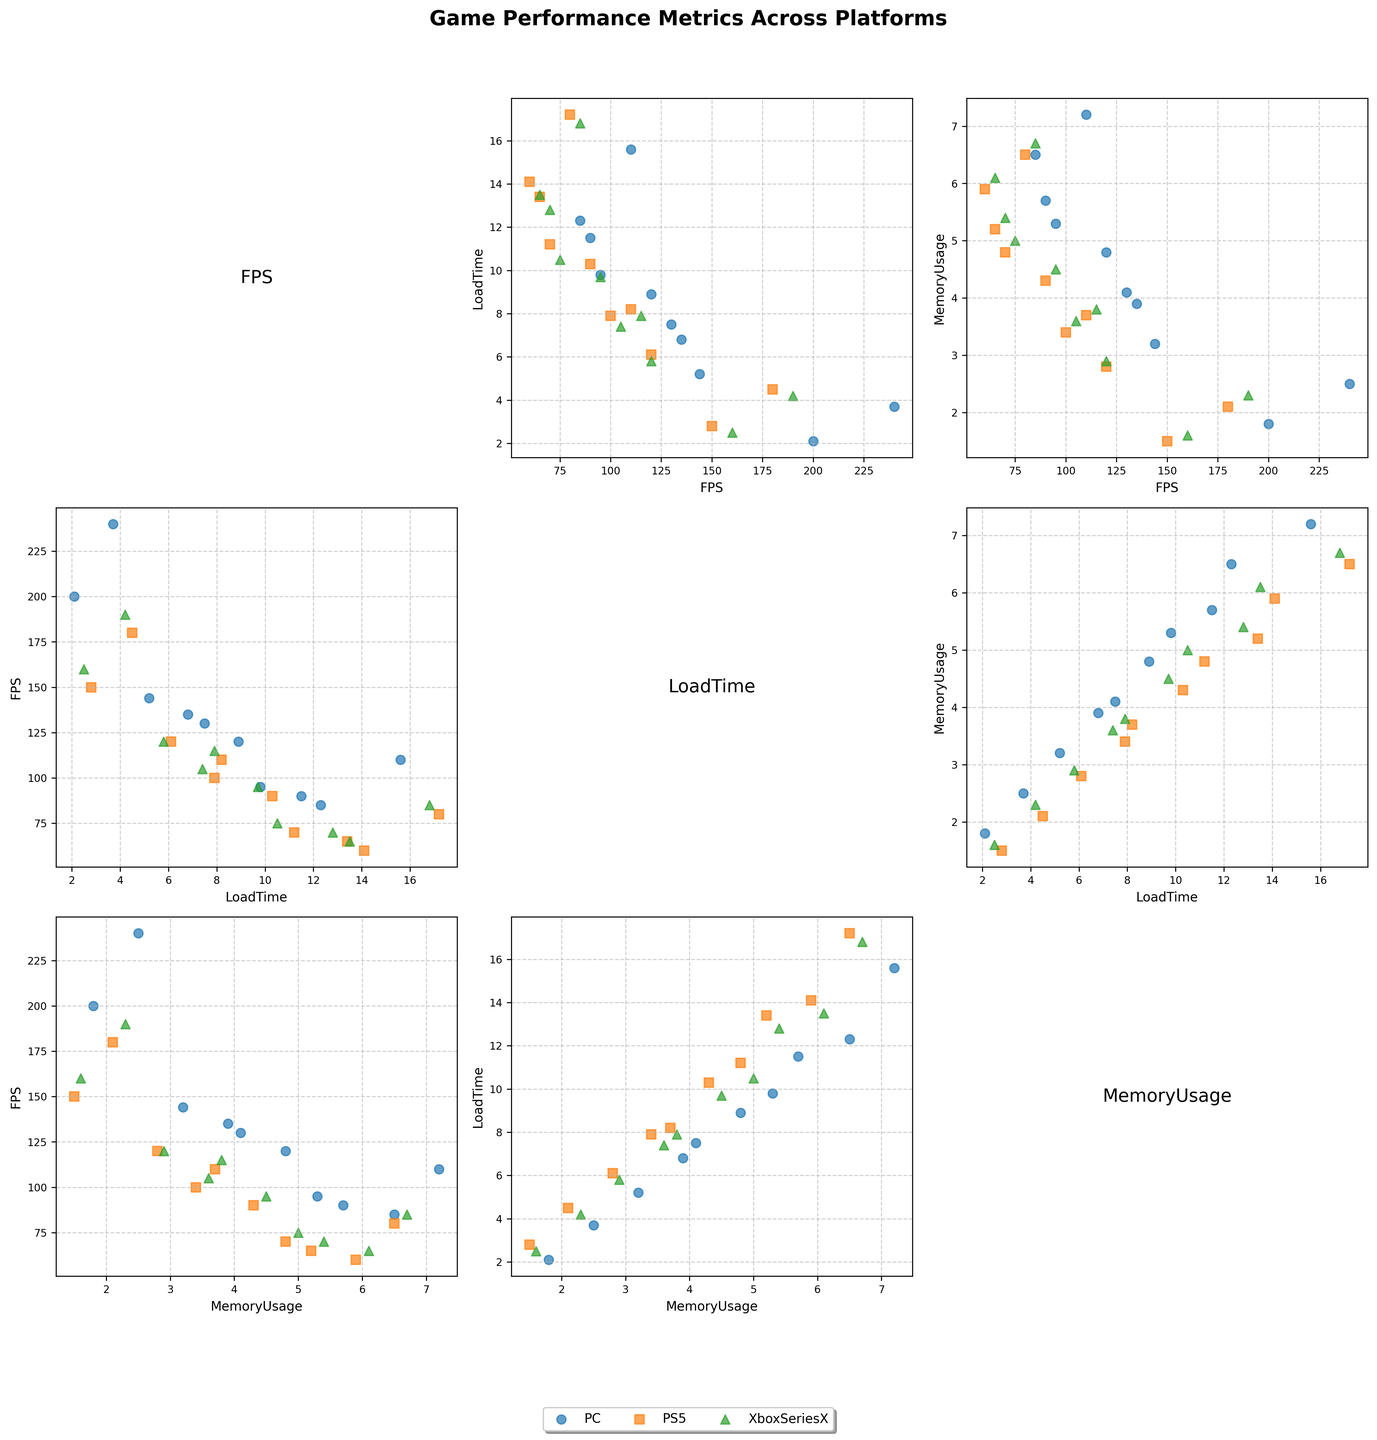What is the title of the figure? The title of the figure is usually located at the top and provides an overview of the data being visualized. In this case, it reads 'Game Performance Metrics Across Platforms'.
Answer: Game Performance Metrics Across Platforms Which color represents the PS5 platform in the scatter plots? To find the color representing PS5, you need to look at the legend located at the lower center of the figure. It indicates the PS5 platform with the color orange.
Answer: Orange Which two games have the lowest FPS on all three platforms? To identify these games, you need to look at the position of the data points in the scatter plots showing FPS against any other metric. Fortnite and Call of Duty: Warzone are positioned higher. Elden Ring and Cyberpunk 2077 have lower FPS across all platforms.
Answer: Elden Ring and Cyberpunk 2077 On which platform does 'Grand Theft Auto V' have the highest FPS? To find this, locate the data points for 'Grand Theft Auto V' in the scatter plot showing FPS metrics. 'Grand Theft Auto V' achieves the highest FPS on the PC platform compared to PS5 and Xbox Series X.
Answer: PC Which platform shows a wider range of load times across different games? Look at the spread of data points for LoadTime on each platform (PC, PS5, XboxSeriesX). The PC platform shows a wider range because its data points are more spread out compared to other platforms.
Answer: PC How does the memory usage for 'Call of Duty: Warzone' compare between PC and Xbox Series X? Locate the data points for 'Call of Duty: Warzone' in the scatter plot for MemoryUsage. Compare the vertical positions of the points for PC and Xbox Series X. Memory usage is higher on PC (4.1) than on Xbox Series X (3.8).
Answer: Higher on PC Which game has the highest LoadTime on the PS5 platform? To identify this game, find the highest data point in the LoadTime_PS5 column in the scatter plots. 'Red Dead Redemption 2' has the highest LoadTime on the PS5 platform.
Answer: Red Dead Redemption 2 Is there a correlation between FPS and LoadTime for the PC platform? To determine this, examine the scatter plot where FPS_PC is on one axis and LoadTime_PC is on the other. Generally, as FPS increases, LoadTime seems to decrease, indicating a negative correlation.
Answer: Yes, negative correlation Compare the FPS for 'FIFA 23' on all three platforms. Which platform performs the worst? Locate the FPS data points for 'FIFA 23' in each scatter plot related to FPS. 'FIFA 23' has the highest FPS on PC (240) and the lowest on PS5 (180), making PS5 the worst-performing platform for FPS.
Answer: PS5 What is the mean LoadTime for 'Cyberpunk 2077' across all platforms? To calculate this, locate the LoadTime data points for 'Cyberpunk 2077' on PC, PS5, and Xbox Series X. Add them up (12.3 + 14.1 + 13.5) and divide by 3. The mean LoadTime is (12.3 + 14.1 + 13.5) / 3 = 13.3 seconds.
Answer: 13.3 seconds 